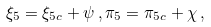Convert formula to latex. <formula><loc_0><loc_0><loc_500><loc_500>{ \xi } _ { 5 } = { \xi } _ { 5 c } + \psi \, , { \pi } _ { 5 } = { \pi } _ { 5 c } + \chi \, ,</formula> 